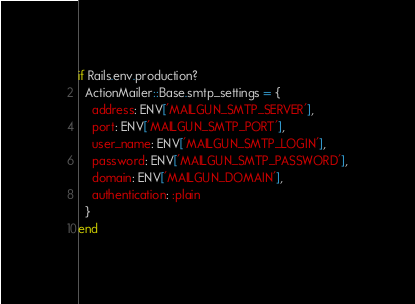<code> <loc_0><loc_0><loc_500><loc_500><_Ruby_>if Rails.env.production?
  ActionMailer::Base.smtp_settings = {
    address: ENV['MAILGUN_SMTP_SERVER'],
    port: ENV['MAILGUN_SMTP_PORT'],
    user_name: ENV['MAILGUN_SMTP_LOGIN'],
    password: ENV['MAILGUN_SMTP_PASSWORD'],
    domain: ENV['MAILGUN_DOMAIN'],
    authentication: :plain
  }
end
</code> 